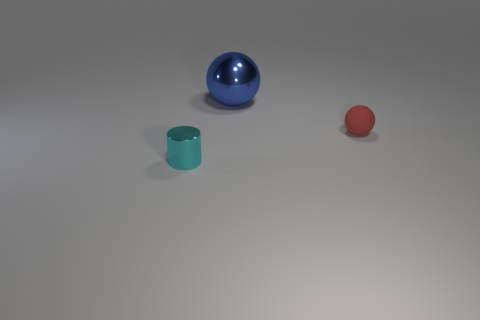Add 1 small metal cylinders. How many objects exist? 4 Subtract all balls. How many objects are left? 1 Add 3 red things. How many red things are left? 4 Add 1 gray metal things. How many gray metal things exist? 1 Subtract 0 purple balls. How many objects are left? 3 Subtract all metallic cylinders. Subtract all tiny cyan shiny objects. How many objects are left? 1 